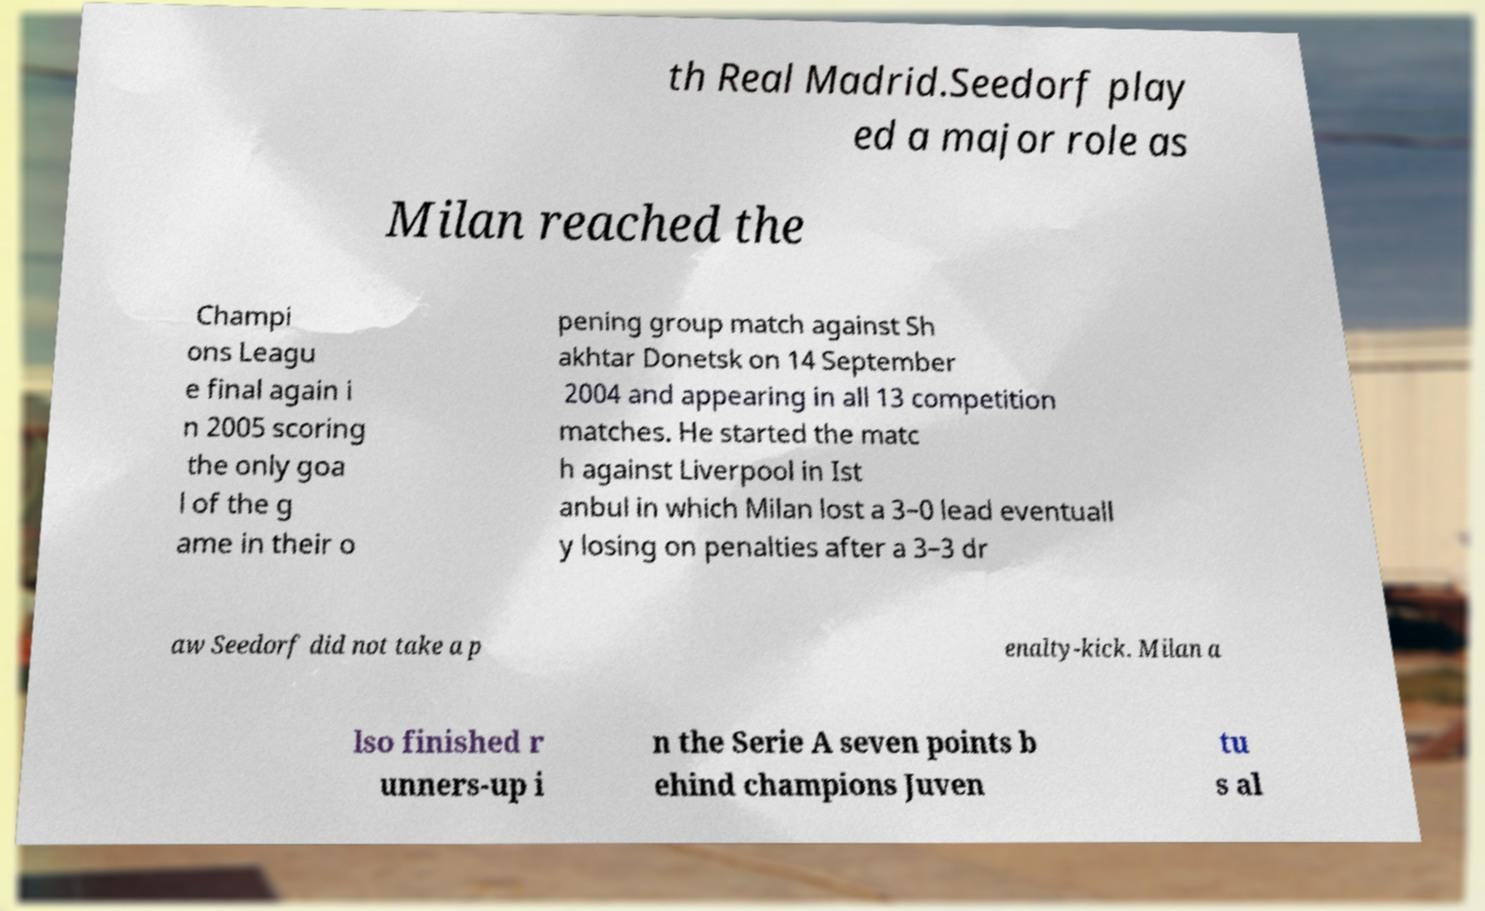Could you extract and type out the text from this image? th Real Madrid.Seedorf play ed a major role as Milan reached the Champi ons Leagu e final again i n 2005 scoring the only goa l of the g ame in their o pening group match against Sh akhtar Donetsk on 14 September 2004 and appearing in all 13 competition matches. He started the matc h against Liverpool in Ist anbul in which Milan lost a 3–0 lead eventuall y losing on penalties after a 3–3 dr aw Seedorf did not take a p enalty-kick. Milan a lso finished r unners-up i n the Serie A seven points b ehind champions Juven tu s al 